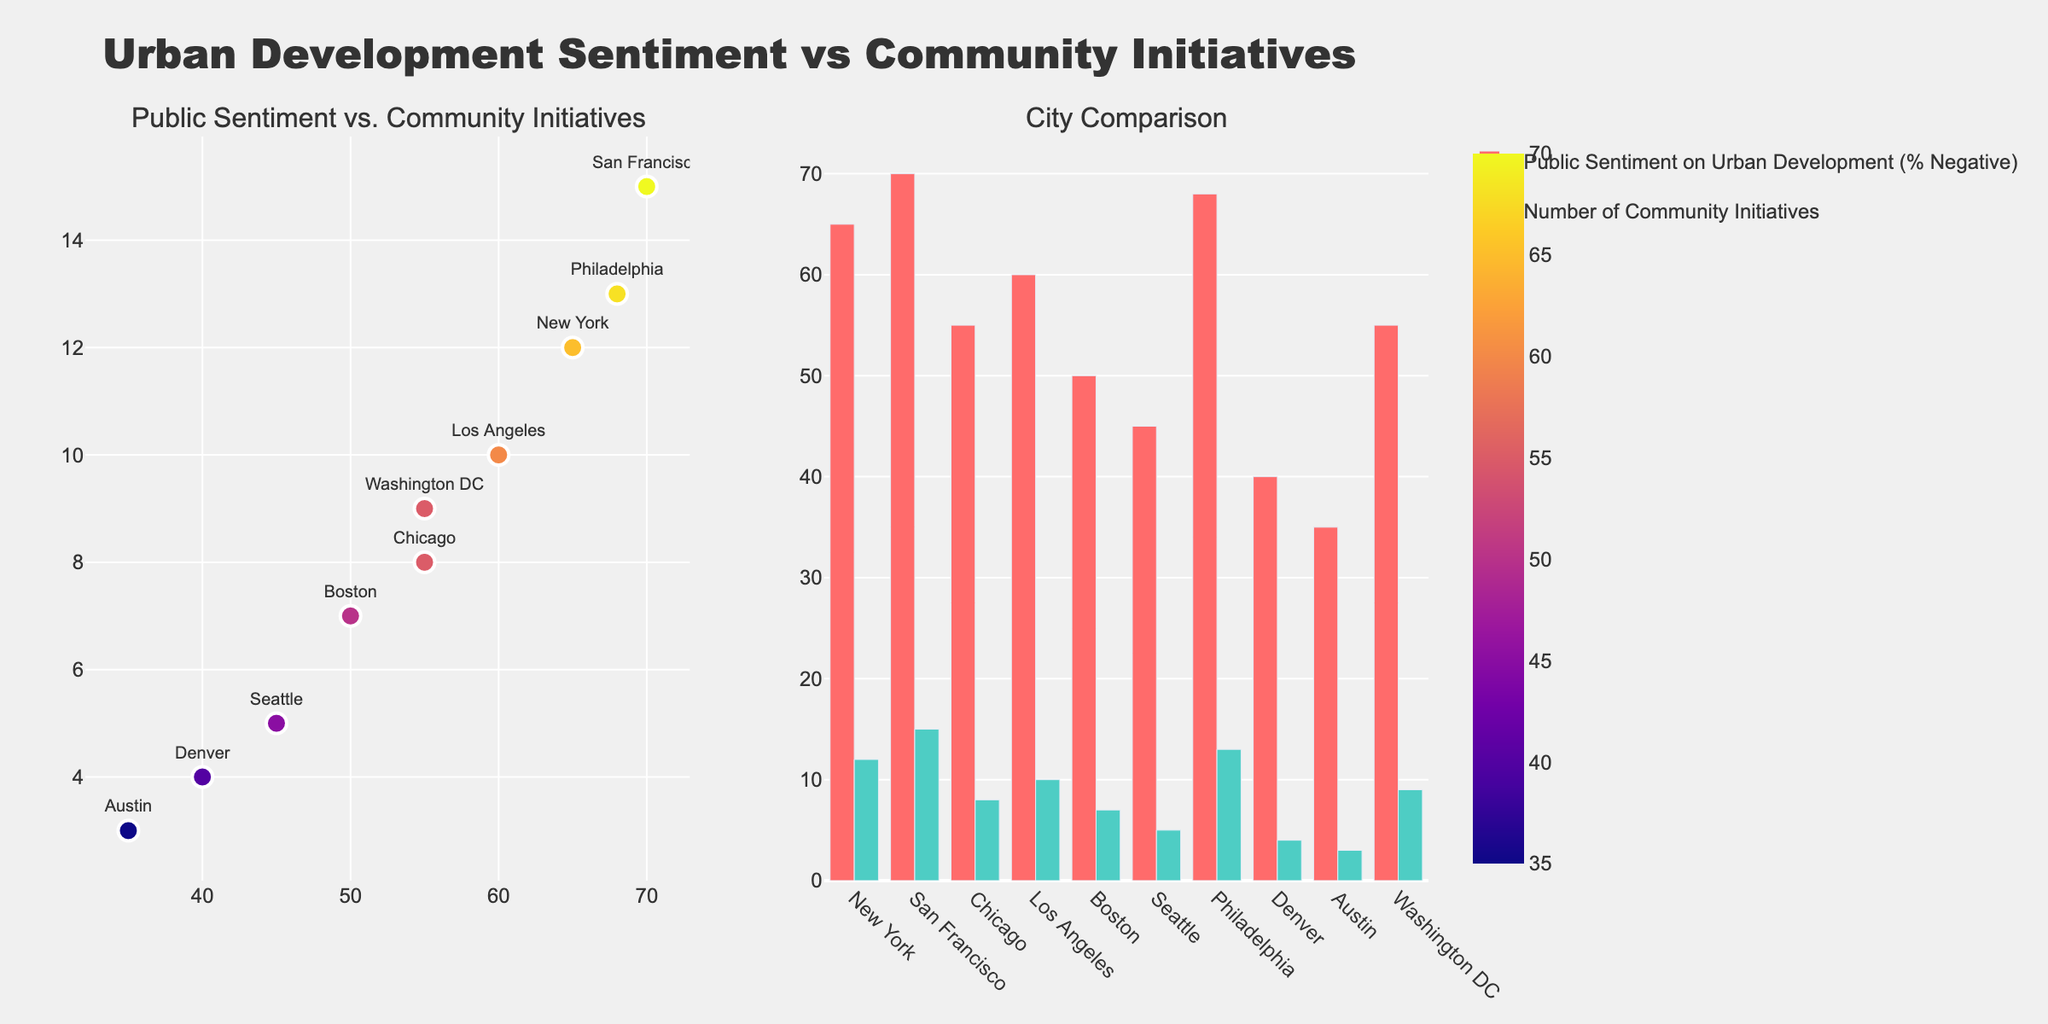what's the title of the figure? The title of the figure is located at the top center and reads, "Urban Development Sentiment vs Community Initiatives".
Answer: Urban Development Sentiment vs Community Initiatives how many cities are represented in the scatter plot? Count the number of unique data points (markers) in the scatter plot; each represents a city.
Answer: 10 which city has the highest negative public sentiment on urban development? In the scatter plot, look for the data point with the highest value on the x-axis, which corresponds to "Public Sentiment on Urban Development (% Negative)".
Answer: San Francisco which city has the fewest community initiatives? Identify the data point with the lowest value on the y-axis of the scatter plot, which represents the "Number of Community Initiatives".
Answer: Austin which city has similar public sentiment and community initiatives to Los Angeles? Find the data point for Los Angeles and identify another data point nearby with similar x-axis and y-axis values.
Answer: Washington DC is there a correlation between public sentiment and the number of community initiatives? Observe the scatter plot trend: points are relatively scattered without a clear upward or downward trend, indicating no obvious correlation.
Answer: No obvious correlation which city has the smallest difference between public sentiment and community initiatives? In the bar chart, find the city with bars closest in height, indicating the smallest difference between "Public Sentiment on Urban Development (% Negative)" and "Number of Community Initiatives".
Answer: Los Angeles what is the combined number of community initiatives for New York and Philadelphia? Add the number of community initiatives for New York and Philadelphia from the data or bar chart: 12 (New York) + 13 (Philadelphia).
Answer: 25 which city has a greater number of community initiatives, Denver or Seattle? Compare the height of the bars for community initiatives for Denver and Seattle in the bar chart.
Answer: Seattle what is the average public sentiment on urban development for all cities? Add all the values for "Public Sentiment on Urban Development (% Negative)" and divide by the number of cities: (65 + 70 + 55 + 60 + 50 + 45 + 68 + 40 + 35 + 55) / 10.
Answer: 54.3 